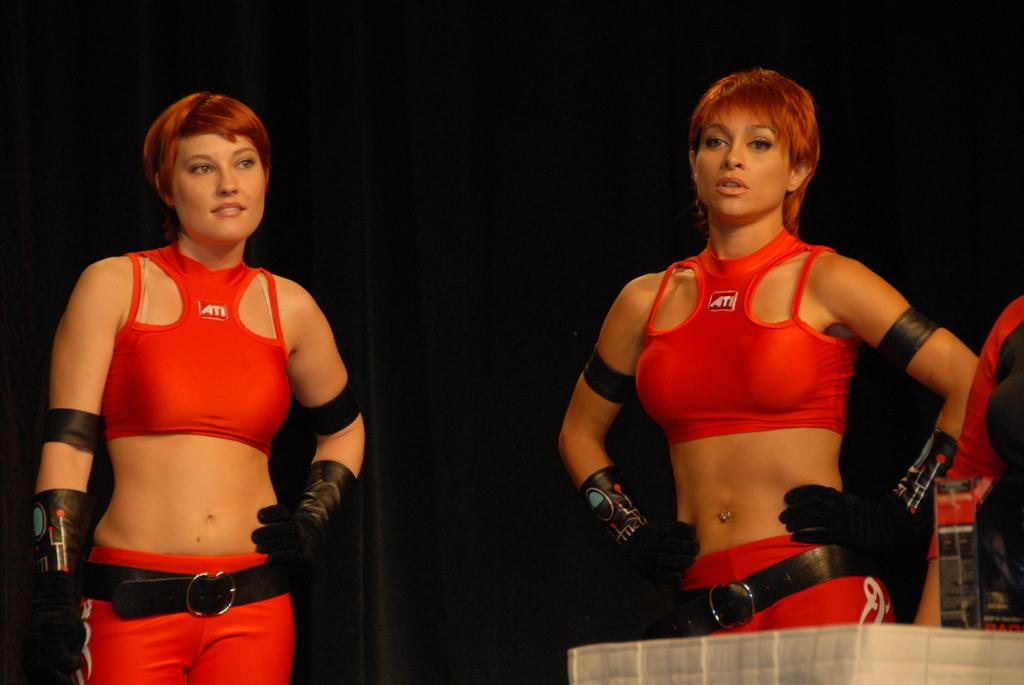<image>
Share a concise interpretation of the image provided. The red tops they have on have the company ATI on them 